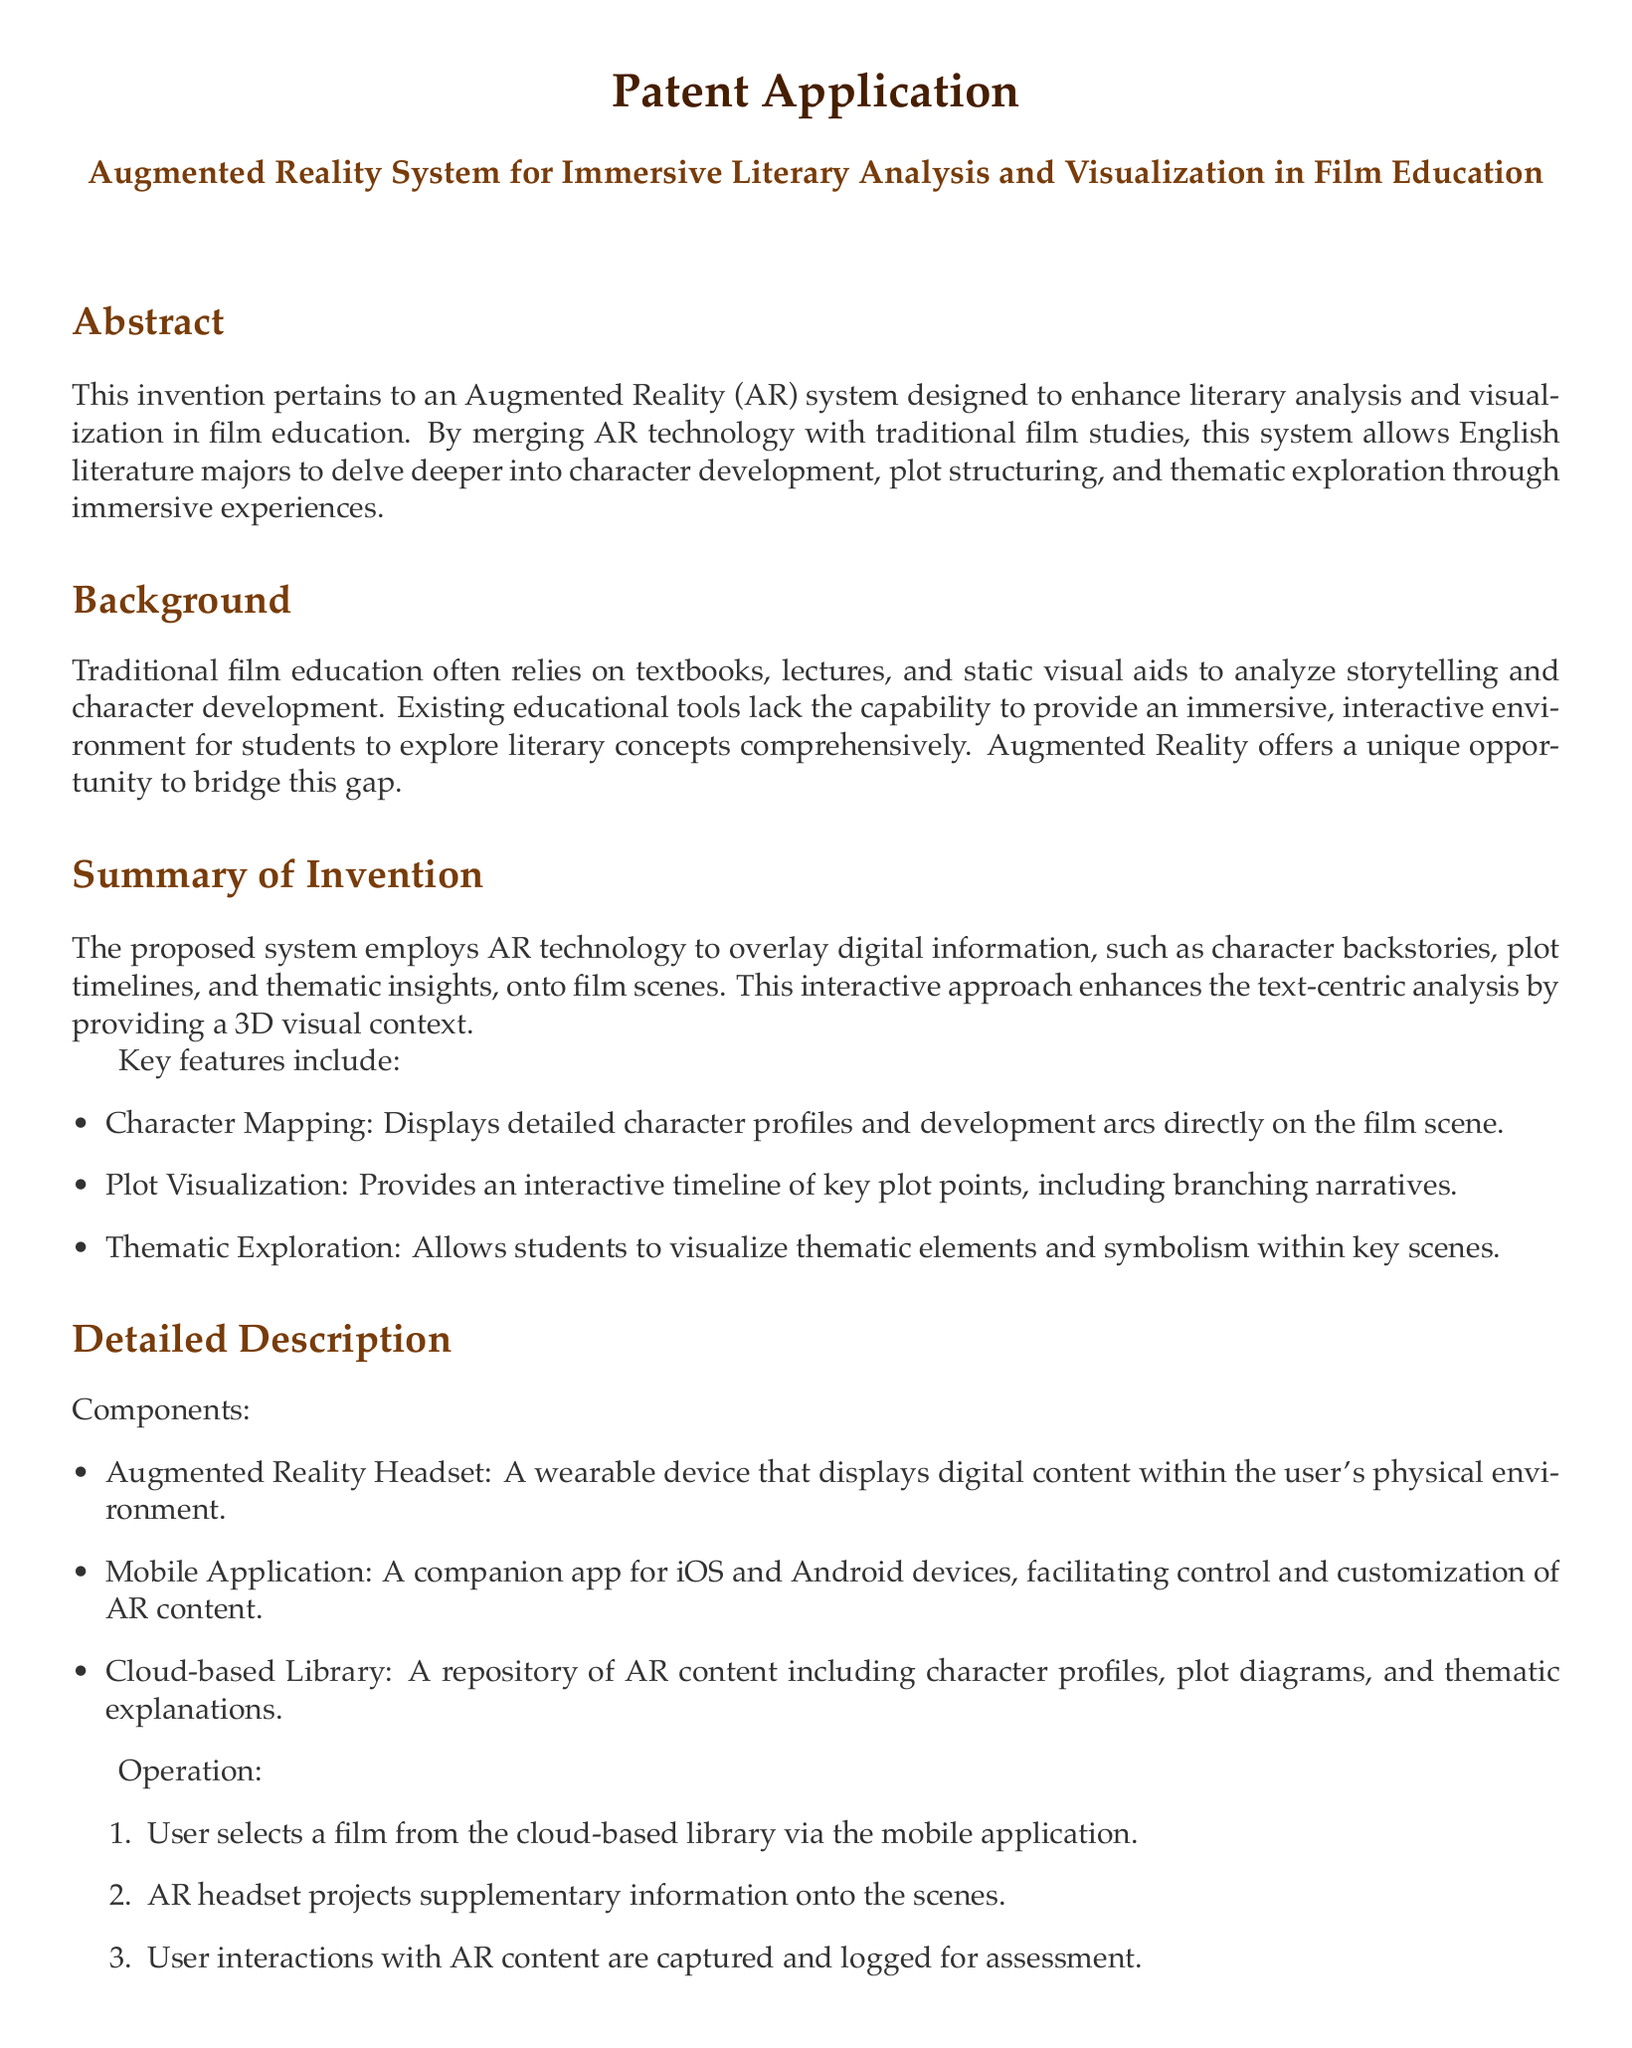What is the title of the patent application? The title is mentioned prominently at the beginning of the document.
Answer: Augmented Reality System for Immersive Literary Analysis and Visualization in Film Education How many key features are listed in the summary of the invention? The number of key features is explicitly stated in the section detailing the summary of the invention.
Answer: Three What device is used to display digital content in the AR system? The device is specified in the components section of the Detailed Description.
Answer: Augmented Reality Headset What type of application accompanies the AR headset? The document specifies the type of application that is designed to work with the AR headset.
Answer: Mobile Application Which educational benefit is highlighted in the advantages section? The document lists specific benefits, and this one is directly quoted in the advantages section.
Answer: Promotes deeper engagement What does the cloud-based library contain? The cloud-based library's contents are briefly outlined in the Detailed Description section.
Answer: Expert-curated resources In how many steps does the operation of the system occur? The number of steps is outlined in the operation section of the Detailed Description.
Answer: Three What specific capability does the mobile application allow for in the AR system? This capability is described in relation to the mobile application's function within the system.
Answer: Selection and customization of AR content What is the primary technological innovation mentioned in the advantages section? This innovation is mentioned under the advantages heading, indicating its unique role in the education system.
Answer: Advanced AR technology 